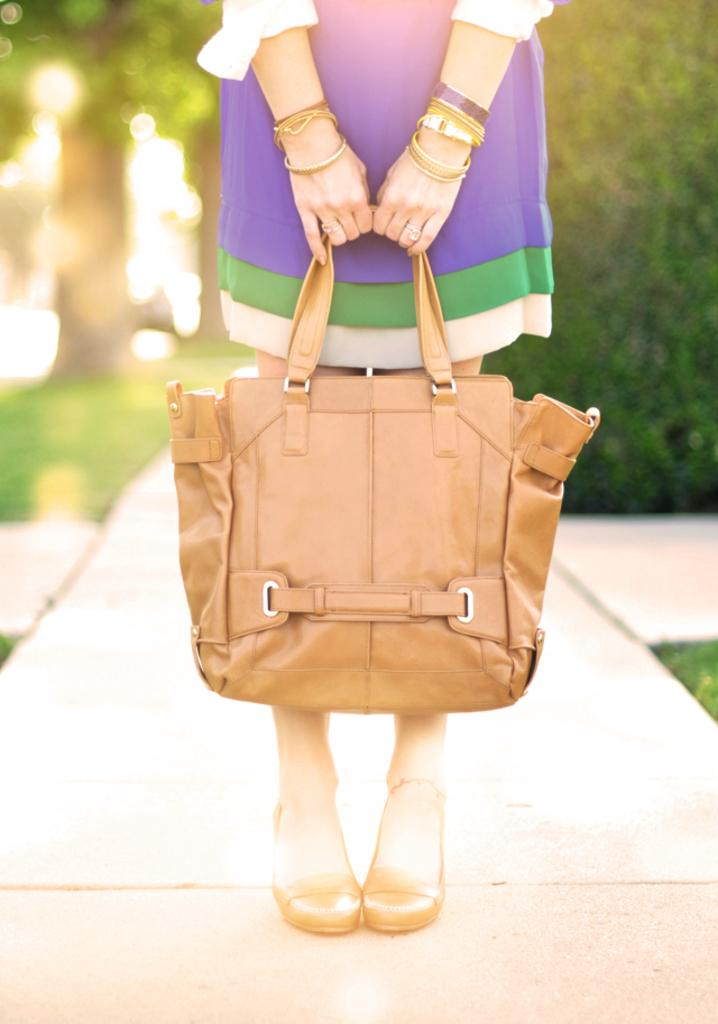Who is present in the image? There is a woman in the image. What is the woman wearing? The woman is wearing a purple skirt. What is the woman holding in the image? The woman is holding a brown bag. What can be seen in the background of the image? There are lights and a plant in the background of the image. What type of peace symbol can be seen in the image? There is no peace symbol present in the image. What kind of flowers are growing in the background of the image? There are no flowers visible in the image; only a plant can be seen in the background. 